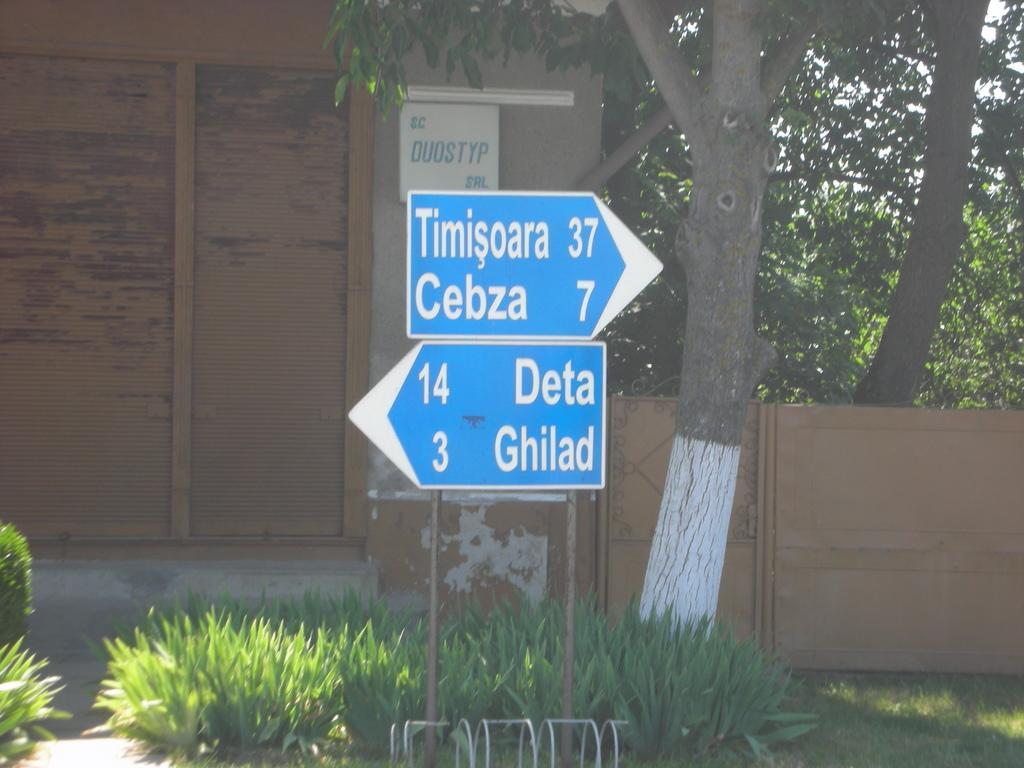How would you summarize this image in a sentence or two? In this image we can see there is a building, trees and a pole with boards and grass under that. 